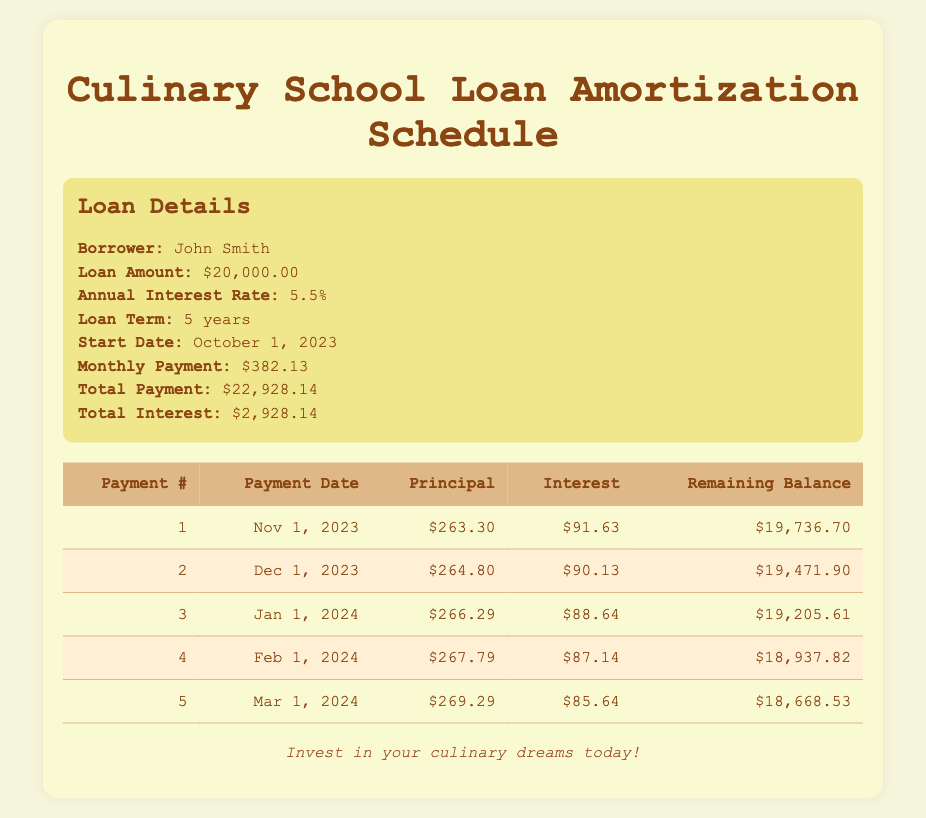What is the total amount of interest paid throughout the loan term? The total amount of interest paid can be found in the loan details. It states that the total interest is $2,928.14.
Answer: $2,928.14 How much was the first principal payment? The first principal payment is indicated in the payment schedule under the column labeled "Principal." It shows that the principal payment for the first payment was $263.30.
Answer: $263.30 What is the remaining balance after the second payment? The remaining balance after the second payment can be found in the row for payment number 2 in the payment schedule. The remaining balance is $19,471.90.
Answer: $19,471.90 What is the difference between the first and fifth principal payments? To find the difference, subtract the fifth principal payment from the first principal payment. The first principal payment is $263.30 and the fifth is $269.29. So, $263.30 - $269.29 = -$5.99. This indicates that the fifth payment is higher by $5.99.
Answer: -$5.99 Is the monthly payment greater than the average monthly principal payment across the first five payments? First, calculate the total principal payments for the first five payments: $263.30 + $264.80 + $266.29 + $267.79 + $269.29 = $1,351.47. Then, divide by 5 for the average: $1,351.47 / 5 = $270.29. Since the monthly payment is $382.13, we can see that $382.13 is greater than $270.29.
Answer: Yes What is the total of the interest payments made in the first five months? The total interest paid in the first five months can be calculated by adding each of the interest payments together: $91.63 + $90.13 + $88.64 + $87.14 + $85.64 = $443.18.
Answer: $443.18 What is the highest principal payment in the first five months? The highest principal payment in the first five months can be found by looking at the "Principal" column. Among the values $263.30, $264.80, $266.29, $267.79, and $269.29, the highest is $269.29 from the fifth payment.
Answer: $269.29 After how many payments will the loan balance fall below $19,000? To find when the loan balance falls below $19,000, we can examine the remaining balances after each payment. After five payments, the remaining balance is $18,668.53, which is below $19,000. This means it will happen after the 5th payment soon after the loan starts.
Answer: After 5 payments What is the total payment amount made after three payments? This can be calculated by multiplying the monthly payment by the number of payments made: $382.13 * 3 = $1,146.39.
Answer: $1,146.39 